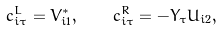Convert formula to latex. <formula><loc_0><loc_0><loc_500><loc_500>c ^ { L } _ { i \tau } = V _ { i 1 } ^ { \ast } , \quad c ^ { R } _ { i \tau } = - Y _ { \tau } U _ { i 2 } ,</formula> 